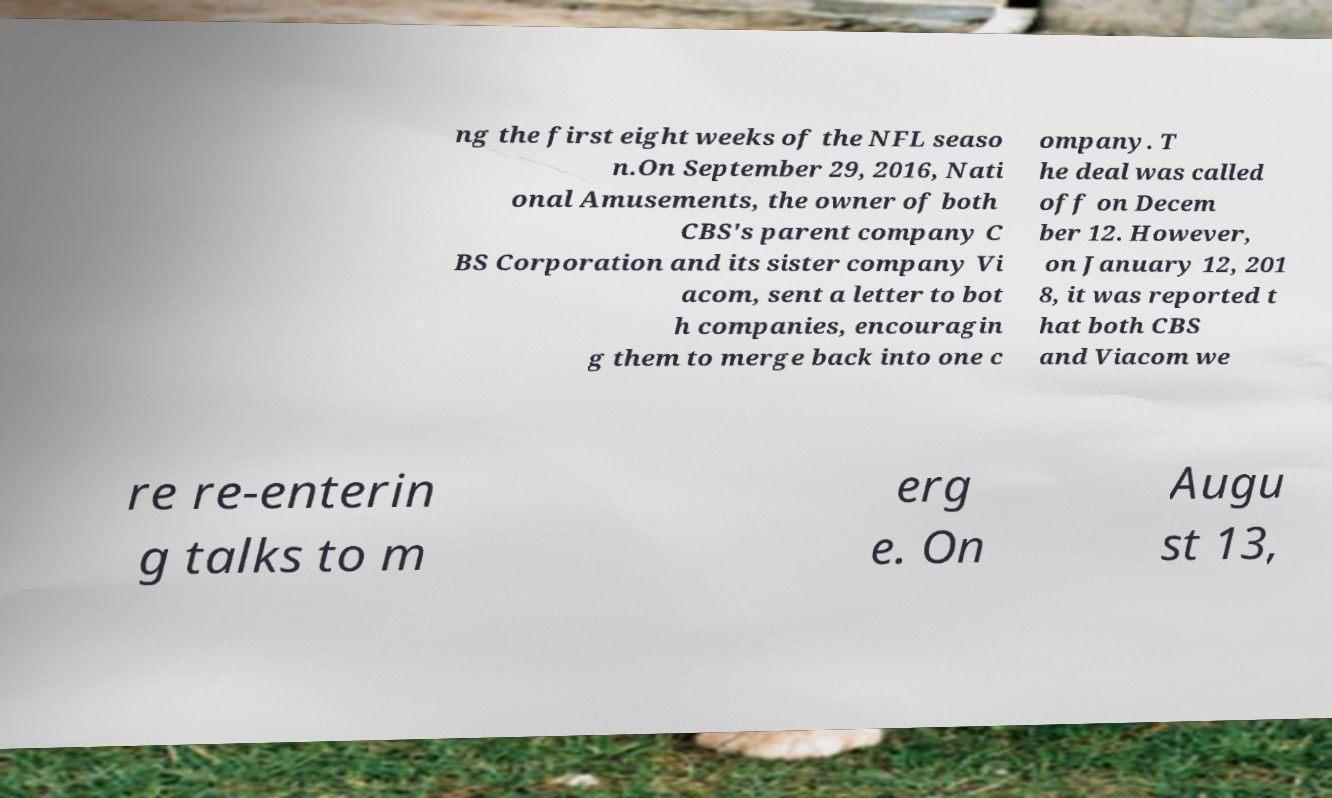There's text embedded in this image that I need extracted. Can you transcribe it verbatim? ng the first eight weeks of the NFL seaso n.On September 29, 2016, Nati onal Amusements, the owner of both CBS's parent company C BS Corporation and its sister company Vi acom, sent a letter to bot h companies, encouragin g them to merge back into one c ompany. T he deal was called off on Decem ber 12. However, on January 12, 201 8, it was reported t hat both CBS and Viacom we re re-enterin g talks to m erg e. On Augu st 13, 